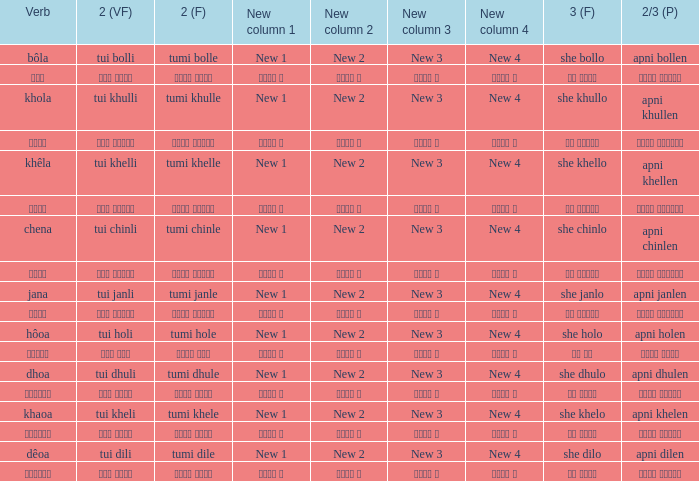What is the verb for Khola? She khullo. 